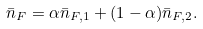<formula> <loc_0><loc_0><loc_500><loc_500>\bar { n } _ { F } = \alpha \bar { n } _ { F , 1 } + ( 1 - \alpha ) \bar { n } _ { F , 2 } .</formula> 